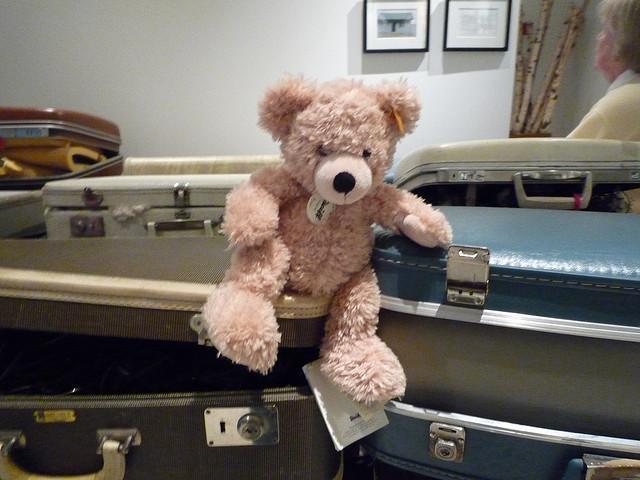Is the caption "The teddy bear is next to the potted plant." a true representation of the image?
Answer yes or no. No. 